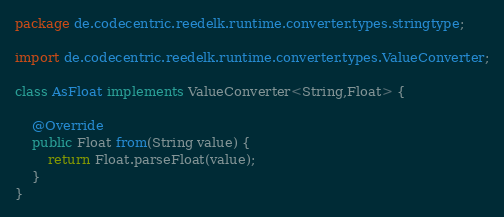Convert code to text. <code><loc_0><loc_0><loc_500><loc_500><_Java_>package de.codecentric.reedelk.runtime.converter.types.stringtype;

import de.codecentric.reedelk.runtime.converter.types.ValueConverter;

class AsFloat implements ValueConverter<String,Float> {

    @Override
    public Float from(String value) {
        return Float.parseFloat(value);
    }
}
</code> 